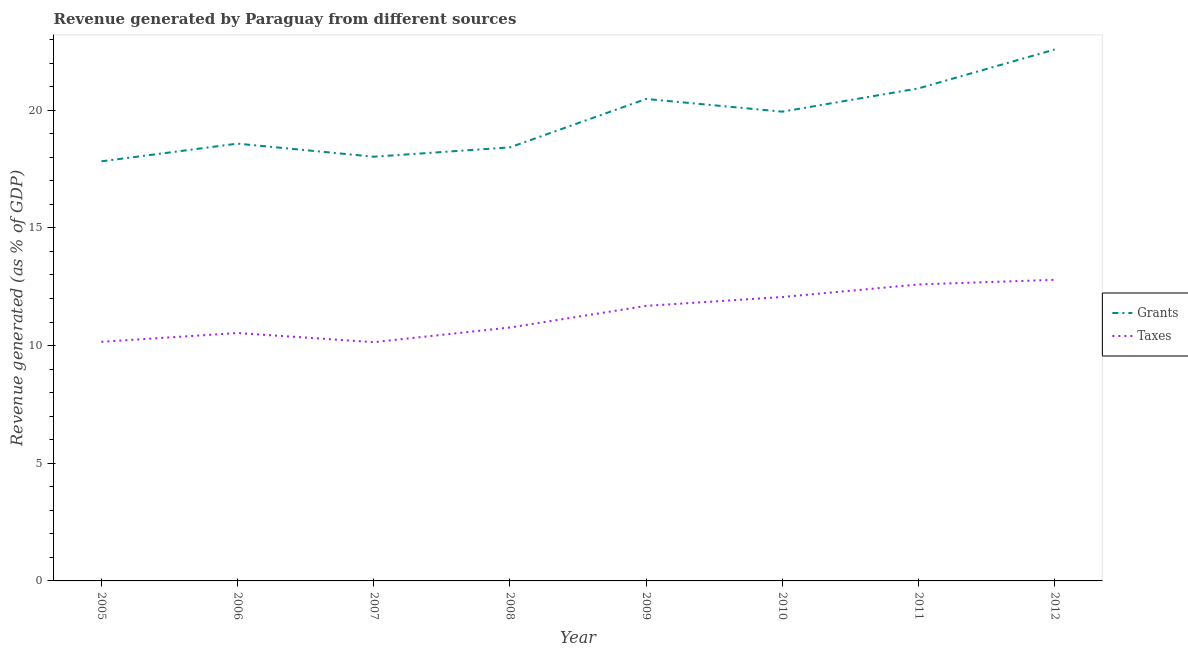How many different coloured lines are there?
Keep it short and to the point. 2. Does the line corresponding to revenue generated by taxes intersect with the line corresponding to revenue generated by grants?
Ensure brevity in your answer.  No. Is the number of lines equal to the number of legend labels?
Provide a succinct answer. Yes. What is the revenue generated by grants in 2005?
Your answer should be compact. 17.83. Across all years, what is the maximum revenue generated by taxes?
Your answer should be very brief. 12.79. Across all years, what is the minimum revenue generated by taxes?
Give a very brief answer. 10.15. In which year was the revenue generated by grants maximum?
Your answer should be very brief. 2012. In which year was the revenue generated by taxes minimum?
Provide a succinct answer. 2007. What is the total revenue generated by taxes in the graph?
Offer a terse response. 90.75. What is the difference between the revenue generated by grants in 2005 and that in 2008?
Your answer should be very brief. -0.59. What is the difference between the revenue generated by grants in 2010 and the revenue generated by taxes in 2009?
Offer a terse response. 8.25. What is the average revenue generated by taxes per year?
Give a very brief answer. 11.34. In the year 2005, what is the difference between the revenue generated by taxes and revenue generated by grants?
Ensure brevity in your answer.  -7.67. What is the ratio of the revenue generated by taxes in 2006 to that in 2011?
Give a very brief answer. 0.84. Is the difference between the revenue generated by grants in 2009 and 2010 greater than the difference between the revenue generated by taxes in 2009 and 2010?
Offer a terse response. Yes. What is the difference between the highest and the second highest revenue generated by taxes?
Provide a succinct answer. 0.2. What is the difference between the highest and the lowest revenue generated by grants?
Provide a succinct answer. 4.75. Is the sum of the revenue generated by taxes in 2007 and 2010 greater than the maximum revenue generated by grants across all years?
Your answer should be compact. No. Does the revenue generated by grants monotonically increase over the years?
Provide a succinct answer. No. Is the revenue generated by taxes strictly greater than the revenue generated by grants over the years?
Offer a terse response. No. How many lines are there?
Your answer should be very brief. 2. What is the difference between two consecutive major ticks on the Y-axis?
Make the answer very short. 5. Are the values on the major ticks of Y-axis written in scientific E-notation?
Give a very brief answer. No. Does the graph contain any zero values?
Make the answer very short. No. Does the graph contain grids?
Give a very brief answer. No. What is the title of the graph?
Your response must be concise. Revenue generated by Paraguay from different sources. What is the label or title of the Y-axis?
Your response must be concise. Revenue generated (as % of GDP). What is the Revenue generated (as % of GDP) in Grants in 2005?
Keep it short and to the point. 17.83. What is the Revenue generated (as % of GDP) of Taxes in 2005?
Provide a short and direct response. 10.16. What is the Revenue generated (as % of GDP) in Grants in 2006?
Offer a very short reply. 18.58. What is the Revenue generated (as % of GDP) in Taxes in 2006?
Offer a very short reply. 10.53. What is the Revenue generated (as % of GDP) of Grants in 2007?
Ensure brevity in your answer.  18.03. What is the Revenue generated (as % of GDP) in Taxes in 2007?
Your answer should be very brief. 10.15. What is the Revenue generated (as % of GDP) in Grants in 2008?
Ensure brevity in your answer.  18.42. What is the Revenue generated (as % of GDP) in Taxes in 2008?
Provide a short and direct response. 10.77. What is the Revenue generated (as % of GDP) in Grants in 2009?
Offer a terse response. 20.48. What is the Revenue generated (as % of GDP) of Taxes in 2009?
Your answer should be very brief. 11.69. What is the Revenue generated (as % of GDP) in Grants in 2010?
Your answer should be compact. 19.94. What is the Revenue generated (as % of GDP) of Taxes in 2010?
Your answer should be compact. 12.06. What is the Revenue generated (as % of GDP) of Grants in 2011?
Offer a very short reply. 20.93. What is the Revenue generated (as % of GDP) in Taxes in 2011?
Provide a short and direct response. 12.6. What is the Revenue generated (as % of GDP) of Grants in 2012?
Your response must be concise. 22.58. What is the Revenue generated (as % of GDP) of Taxes in 2012?
Provide a short and direct response. 12.79. Across all years, what is the maximum Revenue generated (as % of GDP) in Grants?
Provide a short and direct response. 22.58. Across all years, what is the maximum Revenue generated (as % of GDP) in Taxes?
Keep it short and to the point. 12.79. Across all years, what is the minimum Revenue generated (as % of GDP) of Grants?
Provide a short and direct response. 17.83. Across all years, what is the minimum Revenue generated (as % of GDP) of Taxes?
Make the answer very short. 10.15. What is the total Revenue generated (as % of GDP) of Grants in the graph?
Keep it short and to the point. 156.79. What is the total Revenue generated (as % of GDP) of Taxes in the graph?
Offer a very short reply. 90.75. What is the difference between the Revenue generated (as % of GDP) in Grants in 2005 and that in 2006?
Keep it short and to the point. -0.75. What is the difference between the Revenue generated (as % of GDP) in Taxes in 2005 and that in 2006?
Offer a terse response. -0.37. What is the difference between the Revenue generated (as % of GDP) in Grants in 2005 and that in 2007?
Provide a succinct answer. -0.2. What is the difference between the Revenue generated (as % of GDP) in Taxes in 2005 and that in 2007?
Offer a very short reply. 0.01. What is the difference between the Revenue generated (as % of GDP) of Grants in 2005 and that in 2008?
Your answer should be very brief. -0.59. What is the difference between the Revenue generated (as % of GDP) in Taxes in 2005 and that in 2008?
Your response must be concise. -0.61. What is the difference between the Revenue generated (as % of GDP) in Grants in 2005 and that in 2009?
Your response must be concise. -2.65. What is the difference between the Revenue generated (as % of GDP) in Taxes in 2005 and that in 2009?
Offer a terse response. -1.53. What is the difference between the Revenue generated (as % of GDP) of Grants in 2005 and that in 2010?
Provide a short and direct response. -2.11. What is the difference between the Revenue generated (as % of GDP) of Taxes in 2005 and that in 2010?
Offer a very short reply. -1.9. What is the difference between the Revenue generated (as % of GDP) in Grants in 2005 and that in 2011?
Your answer should be very brief. -3.1. What is the difference between the Revenue generated (as % of GDP) in Taxes in 2005 and that in 2011?
Give a very brief answer. -2.44. What is the difference between the Revenue generated (as % of GDP) of Grants in 2005 and that in 2012?
Your answer should be compact. -4.75. What is the difference between the Revenue generated (as % of GDP) of Taxes in 2005 and that in 2012?
Offer a terse response. -2.63. What is the difference between the Revenue generated (as % of GDP) in Grants in 2006 and that in 2007?
Make the answer very short. 0.56. What is the difference between the Revenue generated (as % of GDP) in Taxes in 2006 and that in 2007?
Ensure brevity in your answer.  0.39. What is the difference between the Revenue generated (as % of GDP) of Grants in 2006 and that in 2008?
Offer a very short reply. 0.16. What is the difference between the Revenue generated (as % of GDP) of Taxes in 2006 and that in 2008?
Offer a very short reply. -0.23. What is the difference between the Revenue generated (as % of GDP) of Grants in 2006 and that in 2009?
Provide a succinct answer. -1.9. What is the difference between the Revenue generated (as % of GDP) in Taxes in 2006 and that in 2009?
Your answer should be compact. -1.15. What is the difference between the Revenue generated (as % of GDP) of Grants in 2006 and that in 2010?
Provide a succinct answer. -1.36. What is the difference between the Revenue generated (as % of GDP) of Taxes in 2006 and that in 2010?
Provide a short and direct response. -1.53. What is the difference between the Revenue generated (as % of GDP) of Grants in 2006 and that in 2011?
Your answer should be compact. -2.35. What is the difference between the Revenue generated (as % of GDP) in Taxes in 2006 and that in 2011?
Offer a terse response. -2.06. What is the difference between the Revenue generated (as % of GDP) of Grants in 2006 and that in 2012?
Your answer should be compact. -4. What is the difference between the Revenue generated (as % of GDP) of Taxes in 2006 and that in 2012?
Offer a terse response. -2.26. What is the difference between the Revenue generated (as % of GDP) of Grants in 2007 and that in 2008?
Your answer should be very brief. -0.4. What is the difference between the Revenue generated (as % of GDP) in Taxes in 2007 and that in 2008?
Your answer should be compact. -0.62. What is the difference between the Revenue generated (as % of GDP) of Grants in 2007 and that in 2009?
Provide a short and direct response. -2.45. What is the difference between the Revenue generated (as % of GDP) of Taxes in 2007 and that in 2009?
Offer a terse response. -1.54. What is the difference between the Revenue generated (as % of GDP) of Grants in 2007 and that in 2010?
Offer a very short reply. -1.91. What is the difference between the Revenue generated (as % of GDP) in Taxes in 2007 and that in 2010?
Your response must be concise. -1.92. What is the difference between the Revenue generated (as % of GDP) in Grants in 2007 and that in 2011?
Your answer should be compact. -2.9. What is the difference between the Revenue generated (as % of GDP) of Taxes in 2007 and that in 2011?
Give a very brief answer. -2.45. What is the difference between the Revenue generated (as % of GDP) of Grants in 2007 and that in 2012?
Keep it short and to the point. -4.55. What is the difference between the Revenue generated (as % of GDP) of Taxes in 2007 and that in 2012?
Offer a terse response. -2.65. What is the difference between the Revenue generated (as % of GDP) of Grants in 2008 and that in 2009?
Provide a short and direct response. -2.06. What is the difference between the Revenue generated (as % of GDP) in Taxes in 2008 and that in 2009?
Give a very brief answer. -0.92. What is the difference between the Revenue generated (as % of GDP) in Grants in 2008 and that in 2010?
Your response must be concise. -1.52. What is the difference between the Revenue generated (as % of GDP) of Taxes in 2008 and that in 2010?
Provide a succinct answer. -1.3. What is the difference between the Revenue generated (as % of GDP) in Grants in 2008 and that in 2011?
Provide a short and direct response. -2.51. What is the difference between the Revenue generated (as % of GDP) of Taxes in 2008 and that in 2011?
Keep it short and to the point. -1.83. What is the difference between the Revenue generated (as % of GDP) in Grants in 2008 and that in 2012?
Provide a succinct answer. -4.16. What is the difference between the Revenue generated (as % of GDP) of Taxes in 2008 and that in 2012?
Your answer should be very brief. -2.03. What is the difference between the Revenue generated (as % of GDP) in Grants in 2009 and that in 2010?
Offer a very short reply. 0.54. What is the difference between the Revenue generated (as % of GDP) of Taxes in 2009 and that in 2010?
Your answer should be very brief. -0.38. What is the difference between the Revenue generated (as % of GDP) of Grants in 2009 and that in 2011?
Give a very brief answer. -0.45. What is the difference between the Revenue generated (as % of GDP) of Taxes in 2009 and that in 2011?
Provide a succinct answer. -0.91. What is the difference between the Revenue generated (as % of GDP) of Grants in 2009 and that in 2012?
Make the answer very short. -2.1. What is the difference between the Revenue generated (as % of GDP) of Taxes in 2009 and that in 2012?
Your response must be concise. -1.11. What is the difference between the Revenue generated (as % of GDP) in Grants in 2010 and that in 2011?
Make the answer very short. -0.99. What is the difference between the Revenue generated (as % of GDP) in Taxes in 2010 and that in 2011?
Your answer should be compact. -0.53. What is the difference between the Revenue generated (as % of GDP) in Grants in 2010 and that in 2012?
Make the answer very short. -2.64. What is the difference between the Revenue generated (as % of GDP) in Taxes in 2010 and that in 2012?
Your answer should be compact. -0.73. What is the difference between the Revenue generated (as % of GDP) of Grants in 2011 and that in 2012?
Make the answer very short. -1.65. What is the difference between the Revenue generated (as % of GDP) of Taxes in 2011 and that in 2012?
Make the answer very short. -0.2. What is the difference between the Revenue generated (as % of GDP) in Grants in 2005 and the Revenue generated (as % of GDP) in Taxes in 2006?
Provide a succinct answer. 7.3. What is the difference between the Revenue generated (as % of GDP) of Grants in 2005 and the Revenue generated (as % of GDP) of Taxes in 2007?
Offer a terse response. 7.68. What is the difference between the Revenue generated (as % of GDP) of Grants in 2005 and the Revenue generated (as % of GDP) of Taxes in 2008?
Provide a succinct answer. 7.06. What is the difference between the Revenue generated (as % of GDP) in Grants in 2005 and the Revenue generated (as % of GDP) in Taxes in 2009?
Your response must be concise. 6.14. What is the difference between the Revenue generated (as % of GDP) in Grants in 2005 and the Revenue generated (as % of GDP) in Taxes in 2010?
Give a very brief answer. 5.77. What is the difference between the Revenue generated (as % of GDP) of Grants in 2005 and the Revenue generated (as % of GDP) of Taxes in 2011?
Your answer should be compact. 5.23. What is the difference between the Revenue generated (as % of GDP) of Grants in 2005 and the Revenue generated (as % of GDP) of Taxes in 2012?
Keep it short and to the point. 5.03. What is the difference between the Revenue generated (as % of GDP) in Grants in 2006 and the Revenue generated (as % of GDP) in Taxes in 2007?
Keep it short and to the point. 8.44. What is the difference between the Revenue generated (as % of GDP) in Grants in 2006 and the Revenue generated (as % of GDP) in Taxes in 2008?
Provide a short and direct response. 7.81. What is the difference between the Revenue generated (as % of GDP) in Grants in 2006 and the Revenue generated (as % of GDP) in Taxes in 2009?
Provide a succinct answer. 6.89. What is the difference between the Revenue generated (as % of GDP) of Grants in 2006 and the Revenue generated (as % of GDP) of Taxes in 2010?
Your answer should be compact. 6.52. What is the difference between the Revenue generated (as % of GDP) in Grants in 2006 and the Revenue generated (as % of GDP) in Taxes in 2011?
Offer a very short reply. 5.98. What is the difference between the Revenue generated (as % of GDP) in Grants in 2006 and the Revenue generated (as % of GDP) in Taxes in 2012?
Offer a very short reply. 5.79. What is the difference between the Revenue generated (as % of GDP) in Grants in 2007 and the Revenue generated (as % of GDP) in Taxes in 2008?
Provide a succinct answer. 7.26. What is the difference between the Revenue generated (as % of GDP) in Grants in 2007 and the Revenue generated (as % of GDP) in Taxes in 2009?
Your response must be concise. 6.34. What is the difference between the Revenue generated (as % of GDP) in Grants in 2007 and the Revenue generated (as % of GDP) in Taxes in 2010?
Provide a succinct answer. 5.96. What is the difference between the Revenue generated (as % of GDP) of Grants in 2007 and the Revenue generated (as % of GDP) of Taxes in 2011?
Keep it short and to the point. 5.43. What is the difference between the Revenue generated (as % of GDP) in Grants in 2007 and the Revenue generated (as % of GDP) in Taxes in 2012?
Offer a terse response. 5.23. What is the difference between the Revenue generated (as % of GDP) in Grants in 2008 and the Revenue generated (as % of GDP) in Taxes in 2009?
Your answer should be very brief. 6.74. What is the difference between the Revenue generated (as % of GDP) of Grants in 2008 and the Revenue generated (as % of GDP) of Taxes in 2010?
Your answer should be compact. 6.36. What is the difference between the Revenue generated (as % of GDP) in Grants in 2008 and the Revenue generated (as % of GDP) in Taxes in 2011?
Make the answer very short. 5.82. What is the difference between the Revenue generated (as % of GDP) in Grants in 2008 and the Revenue generated (as % of GDP) in Taxes in 2012?
Your answer should be compact. 5.63. What is the difference between the Revenue generated (as % of GDP) of Grants in 2009 and the Revenue generated (as % of GDP) of Taxes in 2010?
Provide a succinct answer. 8.42. What is the difference between the Revenue generated (as % of GDP) in Grants in 2009 and the Revenue generated (as % of GDP) in Taxes in 2011?
Your answer should be very brief. 7.88. What is the difference between the Revenue generated (as % of GDP) of Grants in 2009 and the Revenue generated (as % of GDP) of Taxes in 2012?
Keep it short and to the point. 7.69. What is the difference between the Revenue generated (as % of GDP) of Grants in 2010 and the Revenue generated (as % of GDP) of Taxes in 2011?
Keep it short and to the point. 7.34. What is the difference between the Revenue generated (as % of GDP) of Grants in 2010 and the Revenue generated (as % of GDP) of Taxes in 2012?
Your response must be concise. 7.15. What is the difference between the Revenue generated (as % of GDP) in Grants in 2011 and the Revenue generated (as % of GDP) in Taxes in 2012?
Offer a terse response. 8.13. What is the average Revenue generated (as % of GDP) of Grants per year?
Make the answer very short. 19.6. What is the average Revenue generated (as % of GDP) of Taxes per year?
Keep it short and to the point. 11.34. In the year 2005, what is the difference between the Revenue generated (as % of GDP) of Grants and Revenue generated (as % of GDP) of Taxes?
Your answer should be compact. 7.67. In the year 2006, what is the difference between the Revenue generated (as % of GDP) of Grants and Revenue generated (as % of GDP) of Taxes?
Give a very brief answer. 8.05. In the year 2007, what is the difference between the Revenue generated (as % of GDP) in Grants and Revenue generated (as % of GDP) in Taxes?
Your answer should be very brief. 7.88. In the year 2008, what is the difference between the Revenue generated (as % of GDP) in Grants and Revenue generated (as % of GDP) in Taxes?
Offer a terse response. 7.65. In the year 2009, what is the difference between the Revenue generated (as % of GDP) in Grants and Revenue generated (as % of GDP) in Taxes?
Make the answer very short. 8.79. In the year 2010, what is the difference between the Revenue generated (as % of GDP) of Grants and Revenue generated (as % of GDP) of Taxes?
Your answer should be compact. 7.88. In the year 2011, what is the difference between the Revenue generated (as % of GDP) of Grants and Revenue generated (as % of GDP) of Taxes?
Provide a short and direct response. 8.33. In the year 2012, what is the difference between the Revenue generated (as % of GDP) of Grants and Revenue generated (as % of GDP) of Taxes?
Ensure brevity in your answer.  9.79. What is the ratio of the Revenue generated (as % of GDP) in Grants in 2005 to that in 2006?
Ensure brevity in your answer.  0.96. What is the ratio of the Revenue generated (as % of GDP) of Taxes in 2005 to that in 2006?
Offer a terse response. 0.96. What is the ratio of the Revenue generated (as % of GDP) of Grants in 2005 to that in 2007?
Provide a short and direct response. 0.99. What is the ratio of the Revenue generated (as % of GDP) of Taxes in 2005 to that in 2007?
Your response must be concise. 1. What is the ratio of the Revenue generated (as % of GDP) in Grants in 2005 to that in 2008?
Offer a terse response. 0.97. What is the ratio of the Revenue generated (as % of GDP) of Taxes in 2005 to that in 2008?
Offer a very short reply. 0.94. What is the ratio of the Revenue generated (as % of GDP) in Grants in 2005 to that in 2009?
Give a very brief answer. 0.87. What is the ratio of the Revenue generated (as % of GDP) of Taxes in 2005 to that in 2009?
Provide a succinct answer. 0.87. What is the ratio of the Revenue generated (as % of GDP) of Grants in 2005 to that in 2010?
Make the answer very short. 0.89. What is the ratio of the Revenue generated (as % of GDP) of Taxes in 2005 to that in 2010?
Provide a short and direct response. 0.84. What is the ratio of the Revenue generated (as % of GDP) of Grants in 2005 to that in 2011?
Your answer should be very brief. 0.85. What is the ratio of the Revenue generated (as % of GDP) of Taxes in 2005 to that in 2011?
Your answer should be very brief. 0.81. What is the ratio of the Revenue generated (as % of GDP) of Grants in 2005 to that in 2012?
Your answer should be very brief. 0.79. What is the ratio of the Revenue generated (as % of GDP) of Taxes in 2005 to that in 2012?
Your answer should be very brief. 0.79. What is the ratio of the Revenue generated (as % of GDP) of Grants in 2006 to that in 2007?
Make the answer very short. 1.03. What is the ratio of the Revenue generated (as % of GDP) of Taxes in 2006 to that in 2007?
Keep it short and to the point. 1.04. What is the ratio of the Revenue generated (as % of GDP) in Grants in 2006 to that in 2008?
Provide a short and direct response. 1.01. What is the ratio of the Revenue generated (as % of GDP) in Taxes in 2006 to that in 2008?
Keep it short and to the point. 0.98. What is the ratio of the Revenue generated (as % of GDP) of Grants in 2006 to that in 2009?
Make the answer very short. 0.91. What is the ratio of the Revenue generated (as % of GDP) in Taxes in 2006 to that in 2009?
Ensure brevity in your answer.  0.9. What is the ratio of the Revenue generated (as % of GDP) in Grants in 2006 to that in 2010?
Your response must be concise. 0.93. What is the ratio of the Revenue generated (as % of GDP) of Taxes in 2006 to that in 2010?
Your response must be concise. 0.87. What is the ratio of the Revenue generated (as % of GDP) in Grants in 2006 to that in 2011?
Give a very brief answer. 0.89. What is the ratio of the Revenue generated (as % of GDP) of Taxes in 2006 to that in 2011?
Keep it short and to the point. 0.84. What is the ratio of the Revenue generated (as % of GDP) of Grants in 2006 to that in 2012?
Your answer should be compact. 0.82. What is the ratio of the Revenue generated (as % of GDP) in Taxes in 2006 to that in 2012?
Offer a terse response. 0.82. What is the ratio of the Revenue generated (as % of GDP) in Grants in 2007 to that in 2008?
Provide a succinct answer. 0.98. What is the ratio of the Revenue generated (as % of GDP) of Taxes in 2007 to that in 2008?
Provide a succinct answer. 0.94. What is the ratio of the Revenue generated (as % of GDP) of Grants in 2007 to that in 2009?
Offer a very short reply. 0.88. What is the ratio of the Revenue generated (as % of GDP) of Taxes in 2007 to that in 2009?
Keep it short and to the point. 0.87. What is the ratio of the Revenue generated (as % of GDP) of Grants in 2007 to that in 2010?
Your answer should be very brief. 0.9. What is the ratio of the Revenue generated (as % of GDP) of Taxes in 2007 to that in 2010?
Offer a very short reply. 0.84. What is the ratio of the Revenue generated (as % of GDP) of Grants in 2007 to that in 2011?
Offer a terse response. 0.86. What is the ratio of the Revenue generated (as % of GDP) of Taxes in 2007 to that in 2011?
Offer a very short reply. 0.81. What is the ratio of the Revenue generated (as % of GDP) of Grants in 2007 to that in 2012?
Your answer should be compact. 0.8. What is the ratio of the Revenue generated (as % of GDP) in Taxes in 2007 to that in 2012?
Your response must be concise. 0.79. What is the ratio of the Revenue generated (as % of GDP) in Grants in 2008 to that in 2009?
Your answer should be very brief. 0.9. What is the ratio of the Revenue generated (as % of GDP) of Taxes in 2008 to that in 2009?
Your answer should be very brief. 0.92. What is the ratio of the Revenue generated (as % of GDP) of Grants in 2008 to that in 2010?
Your answer should be very brief. 0.92. What is the ratio of the Revenue generated (as % of GDP) in Taxes in 2008 to that in 2010?
Provide a short and direct response. 0.89. What is the ratio of the Revenue generated (as % of GDP) in Grants in 2008 to that in 2011?
Your response must be concise. 0.88. What is the ratio of the Revenue generated (as % of GDP) in Taxes in 2008 to that in 2011?
Give a very brief answer. 0.85. What is the ratio of the Revenue generated (as % of GDP) in Grants in 2008 to that in 2012?
Your answer should be very brief. 0.82. What is the ratio of the Revenue generated (as % of GDP) in Taxes in 2008 to that in 2012?
Offer a terse response. 0.84. What is the ratio of the Revenue generated (as % of GDP) of Grants in 2009 to that in 2010?
Ensure brevity in your answer.  1.03. What is the ratio of the Revenue generated (as % of GDP) of Taxes in 2009 to that in 2010?
Offer a terse response. 0.97. What is the ratio of the Revenue generated (as % of GDP) in Grants in 2009 to that in 2011?
Offer a very short reply. 0.98. What is the ratio of the Revenue generated (as % of GDP) in Taxes in 2009 to that in 2011?
Your answer should be compact. 0.93. What is the ratio of the Revenue generated (as % of GDP) of Grants in 2009 to that in 2012?
Provide a short and direct response. 0.91. What is the ratio of the Revenue generated (as % of GDP) in Taxes in 2009 to that in 2012?
Provide a short and direct response. 0.91. What is the ratio of the Revenue generated (as % of GDP) in Grants in 2010 to that in 2011?
Give a very brief answer. 0.95. What is the ratio of the Revenue generated (as % of GDP) of Taxes in 2010 to that in 2011?
Make the answer very short. 0.96. What is the ratio of the Revenue generated (as % of GDP) in Grants in 2010 to that in 2012?
Provide a succinct answer. 0.88. What is the ratio of the Revenue generated (as % of GDP) of Taxes in 2010 to that in 2012?
Your answer should be compact. 0.94. What is the ratio of the Revenue generated (as % of GDP) in Grants in 2011 to that in 2012?
Your answer should be compact. 0.93. What is the ratio of the Revenue generated (as % of GDP) of Taxes in 2011 to that in 2012?
Provide a succinct answer. 0.98. What is the difference between the highest and the second highest Revenue generated (as % of GDP) in Grants?
Ensure brevity in your answer.  1.65. What is the difference between the highest and the second highest Revenue generated (as % of GDP) of Taxes?
Give a very brief answer. 0.2. What is the difference between the highest and the lowest Revenue generated (as % of GDP) of Grants?
Provide a short and direct response. 4.75. What is the difference between the highest and the lowest Revenue generated (as % of GDP) in Taxes?
Give a very brief answer. 2.65. 